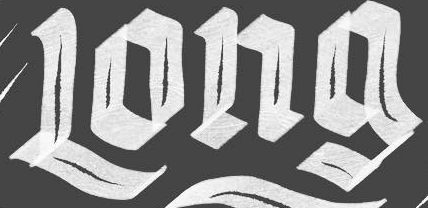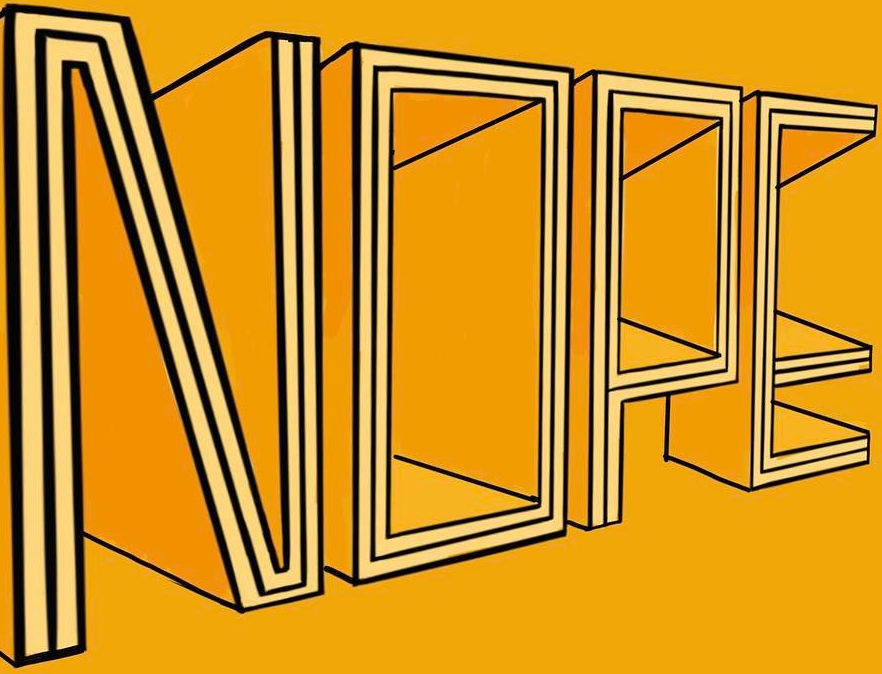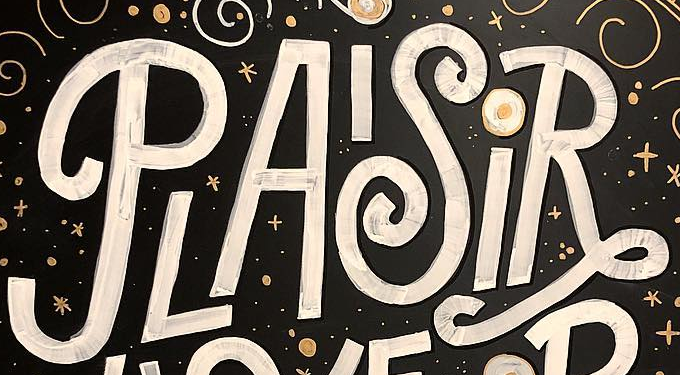What text is displayed in these images sequentially, separated by a semicolon? Long; NOPE; PLAISiR 